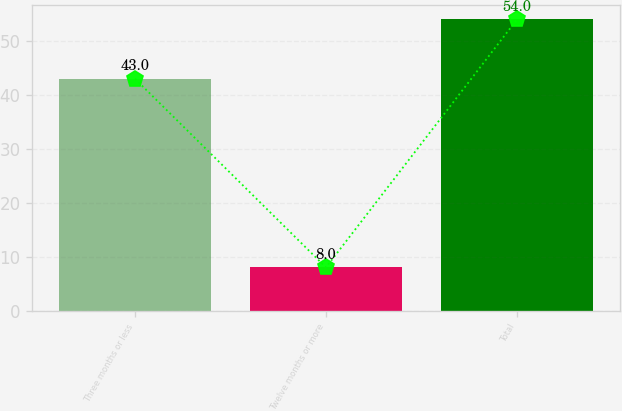Convert chart. <chart><loc_0><loc_0><loc_500><loc_500><bar_chart><fcel>Three months or less<fcel>Twelve months or more<fcel>Total<nl><fcel>43<fcel>8<fcel>54<nl></chart> 